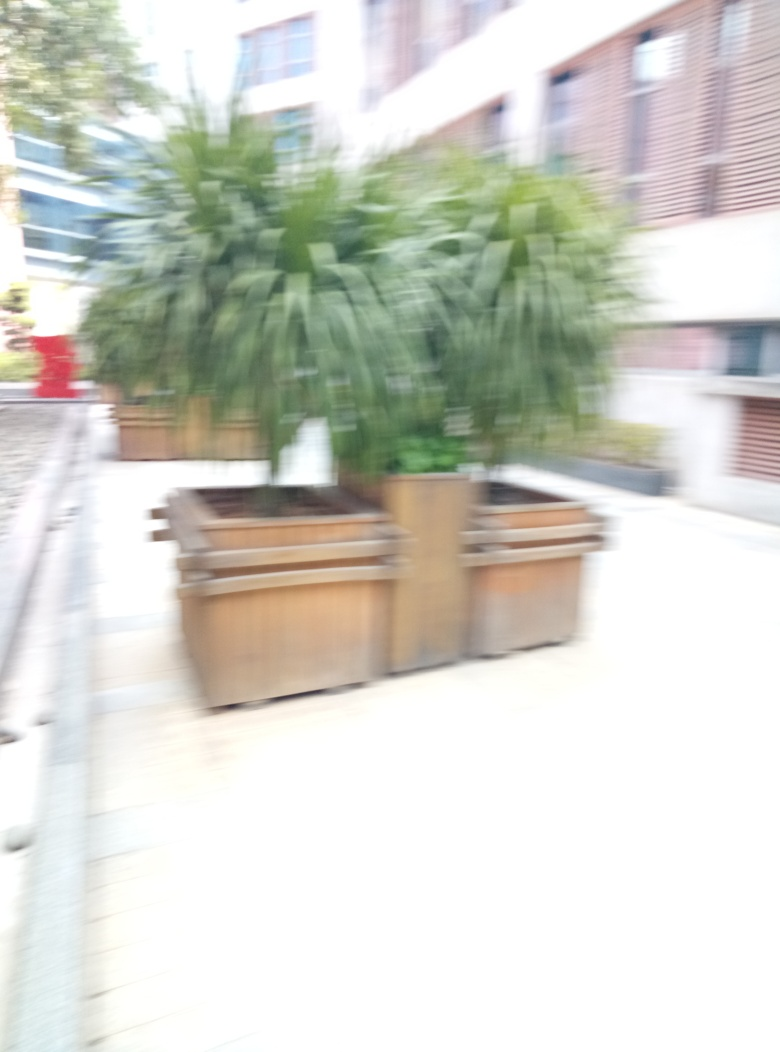Why is the outline of the potted plant blurred? The blurring of the potted plant's outline is likely due to the image being out of focus, which is indicated by option B. This could happen if the camera's auto-focus didn't lock on the subject properly or if a manual focus setting was incorrect. The blurring affects the whole image evenly, suggesting that the camera's focus was not aligned with any objects in the scene. 